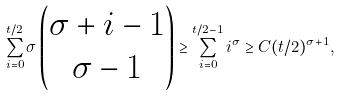<formula> <loc_0><loc_0><loc_500><loc_500>\sum _ { i = 0 } ^ { t / 2 } \sigma \left ( \begin{matrix} \sigma + i - 1 \\ \sigma - 1 \end{matrix} \right ) \geq \sum _ { i = 0 } ^ { t / 2 - 1 } i ^ { \sigma } \geq C ( t / 2 ) ^ { \sigma + 1 } ,</formula> 